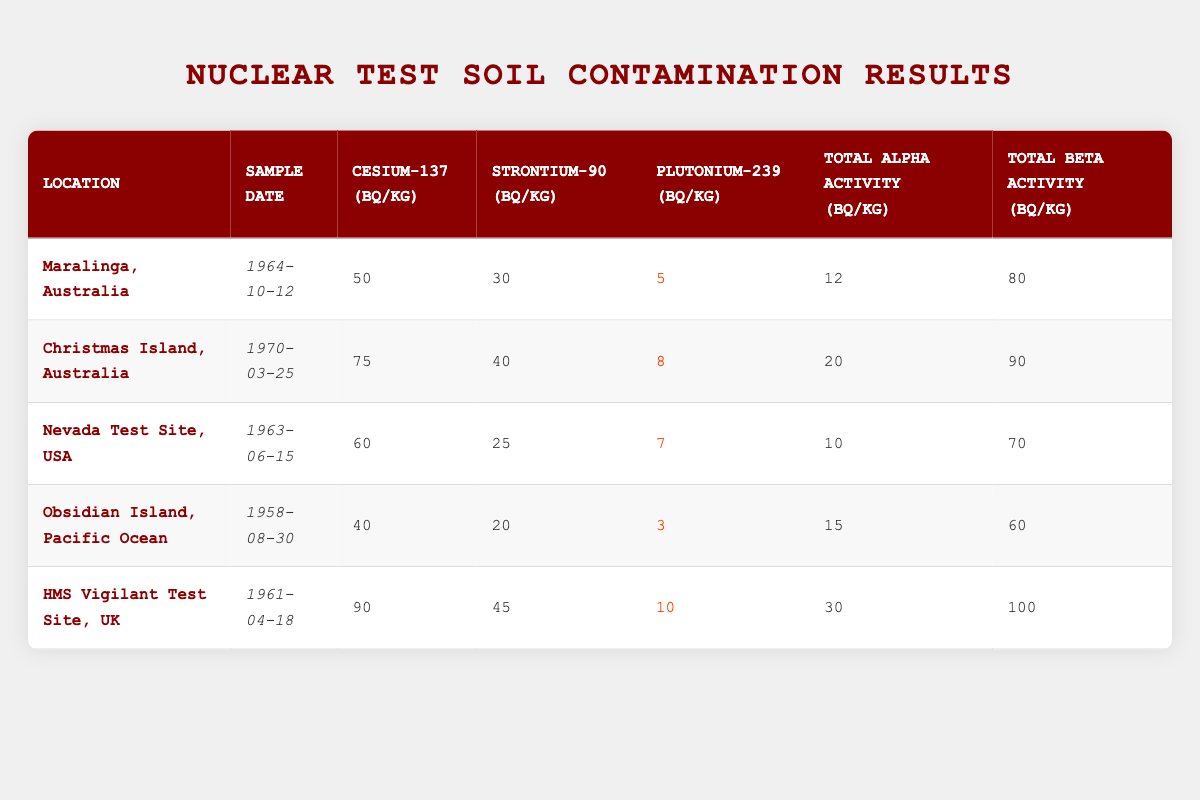What is the cesium-137 level at the HMS Vigilant Test Site? The table shows the cesium-137 level for the HMS Vigilant Test Site, which is listed as 90 Bq/kg.
Answer: 90 Bq/kg What is the date of the soil sample taken from Christmas Island? According to the table, the date of the soil sample from Christmas Island is March 25, 1970.
Answer: March 25, 1970 Which location has the highest total beta activity? Comparing the total beta activity values in the table, the HMS Vigilant Test Site has the highest total beta activity at 100 Bq/kg.
Answer: HMS Vigilant Test Site Is the plutonium-239 level at the Nevada Test Site less than 10 Bq/kg? The table shows that the plutonium-239 level for the Nevada Test Site is 7 Bq/kg, which is indeed less than 10 Bq/kg.
Answer: Yes What is the average strontium-90 level across all locations? To calculate the average strontium-90 level, sum the levels: 30 + 40 + 25 + 20 + 45 = 160. There are 5 data points, so the average is 160/5 = 32.
Answer: 32 Bq/kg How does the total alpha activity at Maralinga compare to the average total alpha activity of all sites? The total alpha activity for Maralinga is 12 Bq/kg. The average of total alpha activity across all sites is calculated by summing: 12 + 20 + 10 + 15 + 30 = 87, and dividing by 5 gives 87/5 = 17.4 Bq/kg. Since 12 is less than 17.4, Maralinga has lower total alpha activity.
Answer: Lower Which site has the lowest cesium-137 contamination level? Looking at the cesium-137 levels: 50 (Maralinga), 75 (Christmas Island), 60 (Nevada Test Site), 40 (Obsidian Island), and 90 (HMS Vigilant). The lowest level is 40 Bq/kg at Obsidian Island.
Answer: Obsidian Island Calculate the total amount of strontium-90 and cesium-137 contamination across all locations. First, sum the cesium-137 levels: 50 + 75 + 60 + 40 + 90 = 315. Then, sum the strontium-90 levels: 30 + 40 + 25 + 20 + 45 = 160. The total contamination level is then 315 + 160 = 475.
Answer: 475 Bq/kg Is the total alpha activity at all sites greater than 25 Bq/kg? The total alpha activities are: 12 (Maralinga), 20 (Christmas Island), 10 (Nevada Test Site), 15 (Obsidian Island), and 30 (HMS Vigilant). Only the HMS Vigilant exceeds 25 Bq/kg. Therefore, not all sites have total alpha activity greater than 25 Bq/kg.
Answer: No 